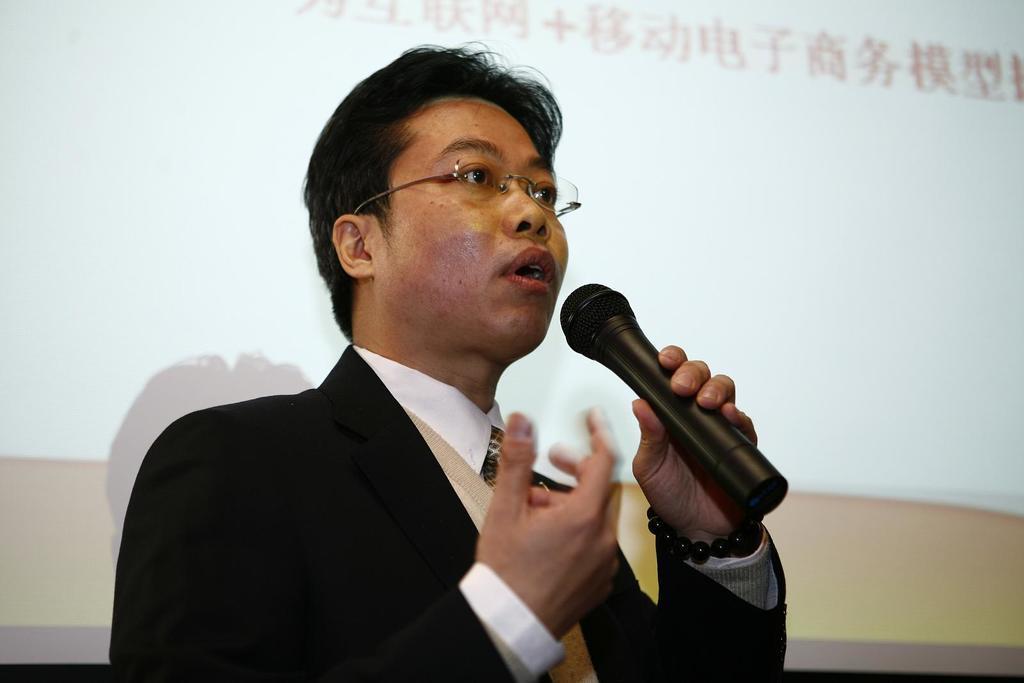Can you describe this image briefly? In this image, man in the suit, he is holding microphone. He is talking. At the background, we can see a screen. A man is wearing glasses. 